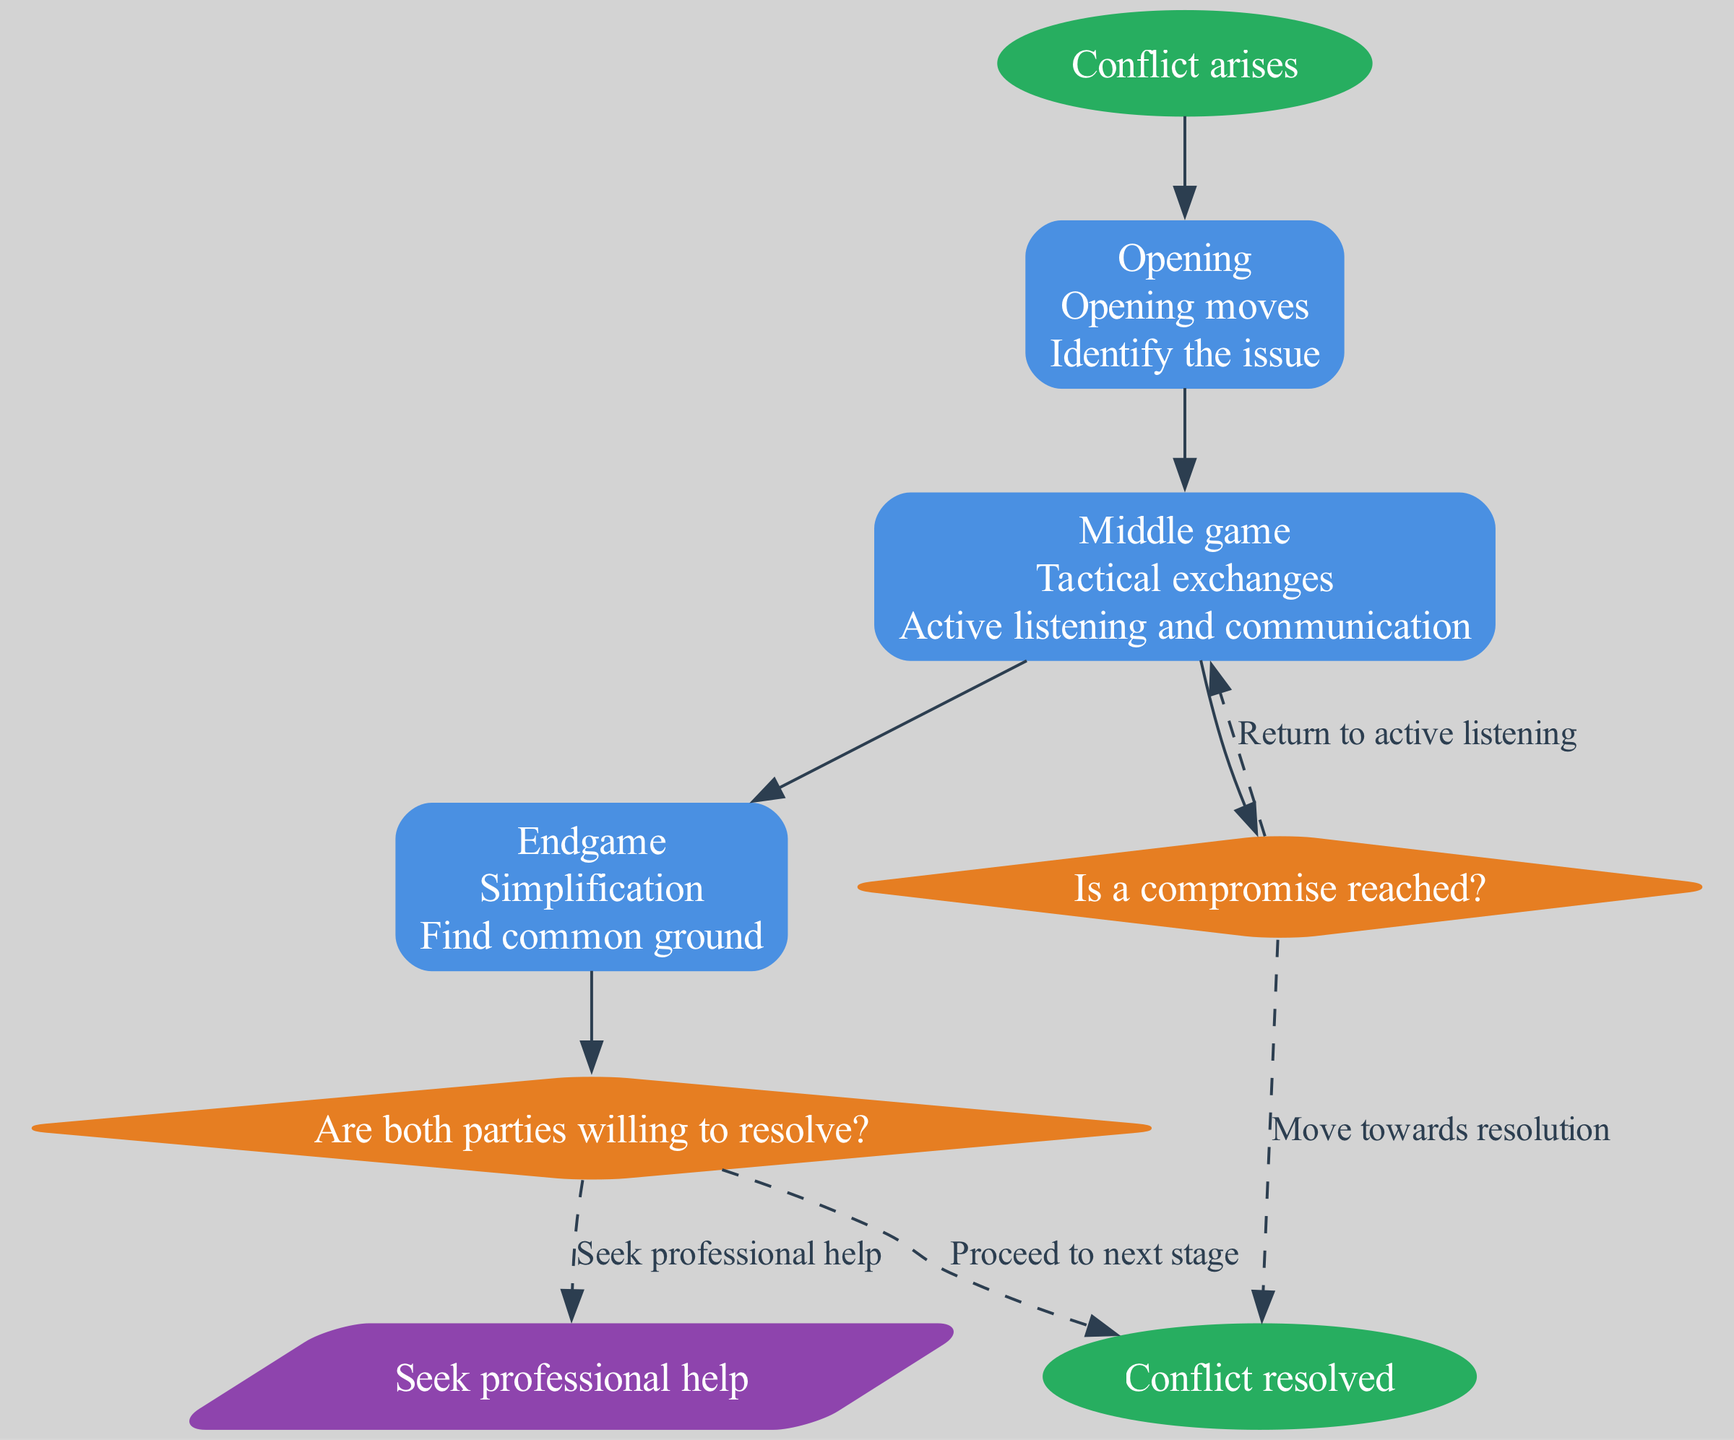What is the starting point of the conflict resolution flow? The starting point is marked as "Conflict arises." This node is the first in the diagram, and it identifies where the process begins.
Answer: Conflict arises How many stages are there in the conflict resolution process? The diagram indicates there are three stages: Opening, Middle game, and Endgame. Counting these shows that there are a total of three distinct stages.
Answer: 3 What action is associated with the "Middle game" stage? The "Middle game" stage corresponds to the action "Active listening and communication," which is detailed in the node for this stage.
Answer: Active listening and communication What question is posed at the first decision point? The first decision point asks, "Are both parties willing to resolve?" This is clearly stated within the diamond-shaped decision node in the diagram.
Answer: Are both parties willing to resolve? If "no" is the answer to the first decision question, what is the next step? The response to a "no" answer at the first decision point indicates to "Seek professional help." This connection is marked out in the flow chart.
Answer: Seek professional help What is the action taken in the "Endgame" stage? The "Endgame" stage is linked to the action "Find common ground." This detail is outlined clearly in the node representing this stage in the diagram.
Answer: Find common ground How does one move from the "Middle game" back to analyzing the issue? If no compromise is reached after the decision point, the flow shows a return to "Active listening," illustrating that further communication is necessary at this stage.
Answer: Return to active listening What type of node connects the actions to the decision points? The nodes describing the stages contain rectangles, while the decision points use diamond shapes to signify choices. This structure helps clarify the flow of the process.
Answer: Rectangles and diamonds What is indicated by the edges of the diagram? The edges represent the flow of actions and decisions, guiding the viewer through the process from one stage to the next based on the responses to questions posed.
Answer: Flow of actions and decisions 